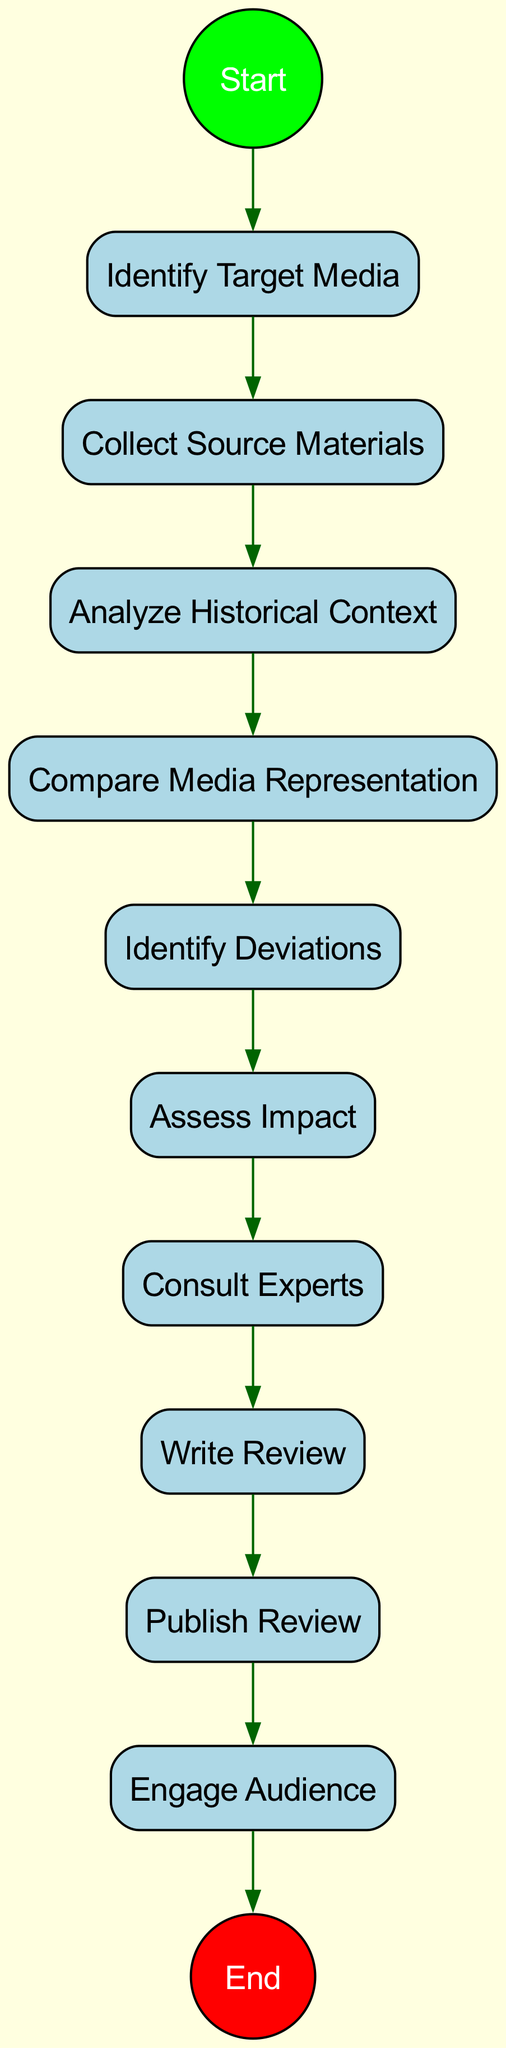What is the first activity in the diagram? The first activity is named "Identify Target Media," which is the starting point for the process of reviewing and critiquing historical accuracy.
Answer: Identify Target Media How many activities are depicted in the diagram? The diagram shows a total of ten activities, each representing a step in the process of evaluating historical accuracy in popular media.
Answer: 10 What is the last activity before the end node? The last activity before the end node is "Publish Review," which is the final step before concluding the process.
Answer: Publish Review Which activity directly follows "Analyze Historical Context"? The activity that directly follows "Analyze Historical Context" is "Compare Media Representation." This shows the sequence in which the activities are conducted.
Answer: Compare Media Representation What is the relationship between "Collect Source Materials" and "Identify Deviations"? "Collect Source Materials" precedes "Identify Deviations," as collecting sources is necessary before one can accurately identify any historical deviations in the media representation.
Answer: Preceding relationship Which activity involves engaging with historians? The activity that involves engaging with historians is "Consult Experts," which is a crucial step in validating the findings of the critique.
Answer: Consult Experts What step comes after "Assess Impact"? The step that follows "Assess Impact" is "Consult Experts," indicating that after assessing the impact of inaccuracies, one should seek expert input.
Answer: Consult Experts How do the activities progress from the start to the end? The activities progress sequentially as follows: Identify Target Media → Collect Source Materials → Analyze Historical Context → Compare Media Representation → Identify Deviations → Assess Impact → Consult Experts → Write Review → Publish Review → Engage Audience, illustrating a logical flow from media selection to audience engagement.
Answer: Sequentially from start to end 